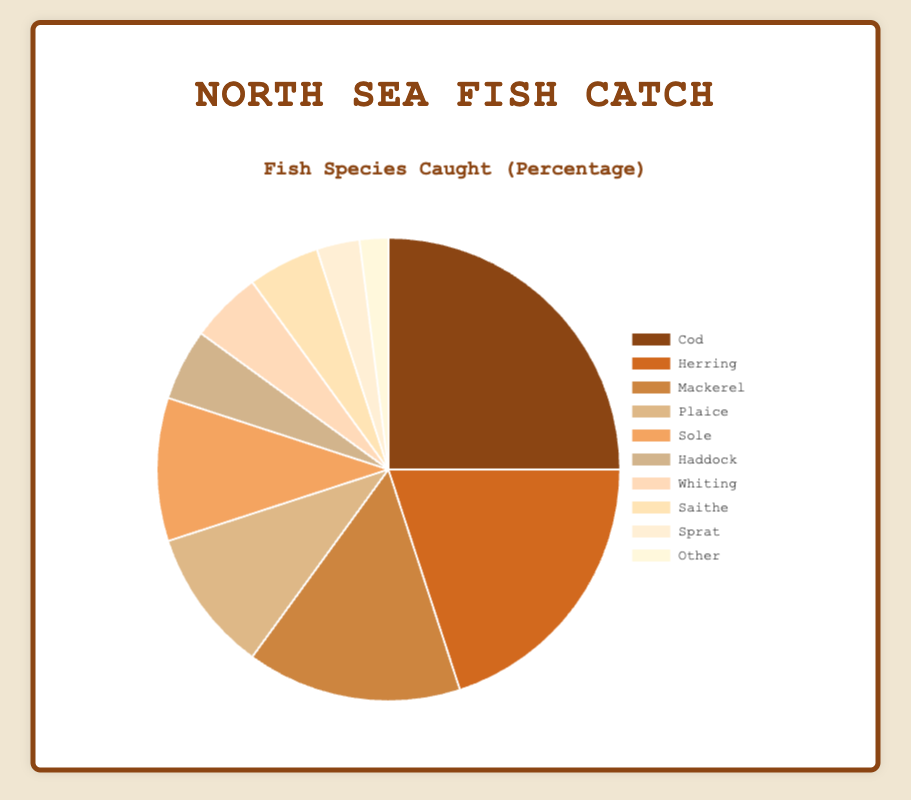What percentage of the fish caught is either Cod or Herring? Add the percentages of Cod (25%) and Herring (20%) together: 25 + 20 = 45
Answer: 45% Which species has the highest percentage of fish caught? Look at the species with the largest percentage value; it is Cod with 25%
Answer: Cod How much more percentage of Cod is caught compared to Saithe? Subtract the percentage of Saithe (5%) from the percentage of Cod (25%): 25 - 5 = 20
Answer: 20% What is the combined percentage of Plaice and Sole? Add the percentages of Plaice (10%) and Sole (10%): 10 + 10 = 20
Answer: 20% Is the percentage of Mackerel caught greater than that of Sole? Compare the percentage values of Mackerel (15%) and Sole (10%): 15 > 10
Answer: Yes Which species account for the smallest percentages of fish caught? Look for the species with the smallest percentage values; they are Sprat (3%) and Other (2%)
Answer: Sprat, Other Combine the percentages of Haddock, Whiting, and Saithe. What do you get? Add the percentages of Haddock (5%), Whiting (5%), and Saithe (5%): 5 + 5 + 5 = 15
Answer: 15% What is the total percentage of the top three most caught species? Add the percentages of Cod (25%), Herring (20%), and Mackerel (15%): 25 + 20 + 15 = 60
Answer: 60% How do the percentages of Haddock and Whiting compare? Both have the same percentage values; Haddock (5%) and Whiting (5%) are equal
Answer: Equal What is the difference in percentage between the least caught species and the most caught species? Subtract the percentage of the least caught species (Other at 2%) from the most caught species (Cod at 25%): 25 - 2 = 23
Answer: 23 